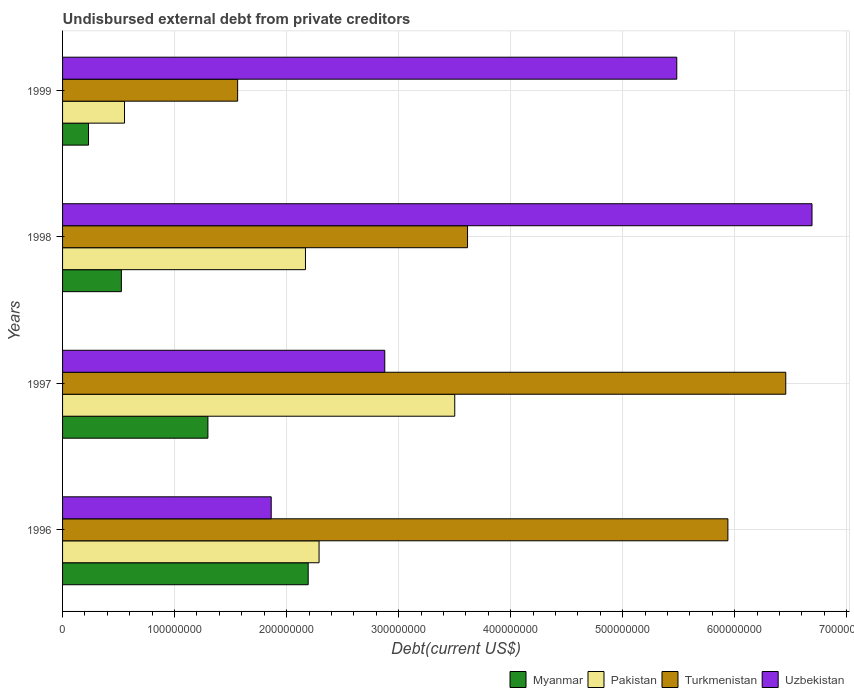How many different coloured bars are there?
Make the answer very short. 4. How many groups of bars are there?
Offer a very short reply. 4. How many bars are there on the 1st tick from the top?
Your answer should be compact. 4. How many bars are there on the 1st tick from the bottom?
Provide a short and direct response. 4. What is the label of the 4th group of bars from the top?
Your answer should be very brief. 1996. What is the total debt in Turkmenistan in 1998?
Your answer should be very brief. 3.62e+08. Across all years, what is the maximum total debt in Pakistan?
Give a very brief answer. 3.50e+08. Across all years, what is the minimum total debt in Uzbekistan?
Offer a terse response. 1.86e+08. What is the total total debt in Pakistan in the graph?
Make the answer very short. 8.51e+08. What is the difference between the total debt in Myanmar in 1997 and that in 1998?
Keep it short and to the point. 7.72e+07. What is the difference between the total debt in Uzbekistan in 1997 and the total debt in Myanmar in 1999?
Make the answer very short. 2.64e+08. What is the average total debt in Uzbekistan per year?
Make the answer very short. 4.23e+08. In the year 1996, what is the difference between the total debt in Pakistan and total debt in Myanmar?
Ensure brevity in your answer.  9.71e+06. What is the ratio of the total debt in Myanmar in 1997 to that in 1998?
Offer a very short reply. 2.47. What is the difference between the highest and the second highest total debt in Turkmenistan?
Make the answer very short. 5.17e+07. What is the difference between the highest and the lowest total debt in Pakistan?
Offer a very short reply. 2.95e+08. Is it the case that in every year, the sum of the total debt in Uzbekistan and total debt in Turkmenistan is greater than the sum of total debt in Myanmar and total debt in Pakistan?
Provide a short and direct response. Yes. What does the 2nd bar from the top in 1998 represents?
Make the answer very short. Turkmenistan. Is it the case that in every year, the sum of the total debt in Turkmenistan and total debt in Myanmar is greater than the total debt in Pakistan?
Provide a short and direct response. Yes. How many years are there in the graph?
Offer a terse response. 4. Are the values on the major ticks of X-axis written in scientific E-notation?
Keep it short and to the point. No. Does the graph contain grids?
Your answer should be very brief. Yes. Where does the legend appear in the graph?
Keep it short and to the point. Bottom right. How many legend labels are there?
Ensure brevity in your answer.  4. What is the title of the graph?
Offer a terse response. Undisbursed external debt from private creditors. Does "Benin" appear as one of the legend labels in the graph?
Offer a terse response. No. What is the label or title of the X-axis?
Keep it short and to the point. Debt(current US$). What is the Debt(current US$) of Myanmar in 1996?
Your response must be concise. 2.19e+08. What is the Debt(current US$) of Pakistan in 1996?
Your answer should be compact. 2.29e+08. What is the Debt(current US$) of Turkmenistan in 1996?
Ensure brevity in your answer.  5.94e+08. What is the Debt(current US$) in Uzbekistan in 1996?
Your answer should be compact. 1.86e+08. What is the Debt(current US$) in Myanmar in 1997?
Give a very brief answer. 1.30e+08. What is the Debt(current US$) of Pakistan in 1997?
Provide a succinct answer. 3.50e+08. What is the Debt(current US$) in Turkmenistan in 1997?
Give a very brief answer. 6.46e+08. What is the Debt(current US$) in Uzbekistan in 1997?
Provide a short and direct response. 2.88e+08. What is the Debt(current US$) of Myanmar in 1998?
Provide a succinct answer. 5.25e+07. What is the Debt(current US$) of Pakistan in 1998?
Make the answer very short. 2.17e+08. What is the Debt(current US$) in Turkmenistan in 1998?
Offer a terse response. 3.62e+08. What is the Debt(current US$) of Uzbekistan in 1998?
Offer a very short reply. 6.69e+08. What is the Debt(current US$) in Myanmar in 1999?
Offer a terse response. 2.32e+07. What is the Debt(current US$) of Pakistan in 1999?
Your answer should be compact. 5.53e+07. What is the Debt(current US$) in Turkmenistan in 1999?
Keep it short and to the point. 1.56e+08. What is the Debt(current US$) of Uzbekistan in 1999?
Give a very brief answer. 5.48e+08. Across all years, what is the maximum Debt(current US$) in Myanmar?
Ensure brevity in your answer.  2.19e+08. Across all years, what is the maximum Debt(current US$) in Pakistan?
Ensure brevity in your answer.  3.50e+08. Across all years, what is the maximum Debt(current US$) in Turkmenistan?
Make the answer very short. 6.46e+08. Across all years, what is the maximum Debt(current US$) of Uzbekistan?
Your answer should be compact. 6.69e+08. Across all years, what is the minimum Debt(current US$) in Myanmar?
Provide a succinct answer. 2.32e+07. Across all years, what is the minimum Debt(current US$) in Pakistan?
Your response must be concise. 5.53e+07. Across all years, what is the minimum Debt(current US$) in Turkmenistan?
Give a very brief answer. 1.56e+08. Across all years, what is the minimum Debt(current US$) of Uzbekistan?
Make the answer very short. 1.86e+08. What is the total Debt(current US$) of Myanmar in the graph?
Make the answer very short. 4.25e+08. What is the total Debt(current US$) of Pakistan in the graph?
Offer a terse response. 8.51e+08. What is the total Debt(current US$) of Turkmenistan in the graph?
Your answer should be compact. 1.76e+09. What is the total Debt(current US$) of Uzbekistan in the graph?
Give a very brief answer. 1.69e+09. What is the difference between the Debt(current US$) in Myanmar in 1996 and that in 1997?
Your response must be concise. 8.95e+07. What is the difference between the Debt(current US$) in Pakistan in 1996 and that in 1997?
Offer a very short reply. -1.21e+08. What is the difference between the Debt(current US$) of Turkmenistan in 1996 and that in 1997?
Keep it short and to the point. -5.17e+07. What is the difference between the Debt(current US$) of Uzbekistan in 1996 and that in 1997?
Your answer should be compact. -1.01e+08. What is the difference between the Debt(current US$) in Myanmar in 1996 and that in 1998?
Keep it short and to the point. 1.67e+08. What is the difference between the Debt(current US$) of Pakistan in 1996 and that in 1998?
Make the answer very short. 1.21e+07. What is the difference between the Debt(current US$) of Turkmenistan in 1996 and that in 1998?
Ensure brevity in your answer.  2.32e+08. What is the difference between the Debt(current US$) of Uzbekistan in 1996 and that in 1998?
Offer a very short reply. -4.83e+08. What is the difference between the Debt(current US$) of Myanmar in 1996 and that in 1999?
Make the answer very short. 1.96e+08. What is the difference between the Debt(current US$) of Pakistan in 1996 and that in 1999?
Make the answer very short. 1.74e+08. What is the difference between the Debt(current US$) in Turkmenistan in 1996 and that in 1999?
Make the answer very short. 4.38e+08. What is the difference between the Debt(current US$) of Uzbekistan in 1996 and that in 1999?
Offer a terse response. -3.62e+08. What is the difference between the Debt(current US$) in Myanmar in 1997 and that in 1998?
Make the answer very short. 7.72e+07. What is the difference between the Debt(current US$) in Pakistan in 1997 and that in 1998?
Provide a succinct answer. 1.33e+08. What is the difference between the Debt(current US$) of Turkmenistan in 1997 and that in 1998?
Offer a very short reply. 2.84e+08. What is the difference between the Debt(current US$) in Uzbekistan in 1997 and that in 1998?
Offer a very short reply. -3.81e+08. What is the difference between the Debt(current US$) of Myanmar in 1997 and that in 1999?
Offer a very short reply. 1.07e+08. What is the difference between the Debt(current US$) of Pakistan in 1997 and that in 1999?
Offer a terse response. 2.95e+08. What is the difference between the Debt(current US$) of Turkmenistan in 1997 and that in 1999?
Ensure brevity in your answer.  4.89e+08. What is the difference between the Debt(current US$) in Uzbekistan in 1997 and that in 1999?
Offer a very short reply. -2.61e+08. What is the difference between the Debt(current US$) of Myanmar in 1998 and that in 1999?
Provide a short and direct response. 2.93e+07. What is the difference between the Debt(current US$) of Pakistan in 1998 and that in 1999?
Offer a very short reply. 1.62e+08. What is the difference between the Debt(current US$) of Turkmenistan in 1998 and that in 1999?
Your answer should be very brief. 2.05e+08. What is the difference between the Debt(current US$) in Uzbekistan in 1998 and that in 1999?
Provide a short and direct response. 1.21e+08. What is the difference between the Debt(current US$) in Myanmar in 1996 and the Debt(current US$) in Pakistan in 1997?
Ensure brevity in your answer.  -1.31e+08. What is the difference between the Debt(current US$) in Myanmar in 1996 and the Debt(current US$) in Turkmenistan in 1997?
Provide a succinct answer. -4.26e+08. What is the difference between the Debt(current US$) in Myanmar in 1996 and the Debt(current US$) in Uzbekistan in 1997?
Provide a short and direct response. -6.84e+07. What is the difference between the Debt(current US$) of Pakistan in 1996 and the Debt(current US$) of Turkmenistan in 1997?
Your answer should be compact. -4.17e+08. What is the difference between the Debt(current US$) in Pakistan in 1996 and the Debt(current US$) in Uzbekistan in 1997?
Keep it short and to the point. -5.87e+07. What is the difference between the Debt(current US$) in Turkmenistan in 1996 and the Debt(current US$) in Uzbekistan in 1997?
Your answer should be compact. 3.06e+08. What is the difference between the Debt(current US$) in Myanmar in 1996 and the Debt(current US$) in Pakistan in 1998?
Offer a terse response. 2.43e+06. What is the difference between the Debt(current US$) in Myanmar in 1996 and the Debt(current US$) in Turkmenistan in 1998?
Your answer should be very brief. -1.42e+08. What is the difference between the Debt(current US$) in Myanmar in 1996 and the Debt(current US$) in Uzbekistan in 1998?
Provide a short and direct response. -4.50e+08. What is the difference between the Debt(current US$) of Pakistan in 1996 and the Debt(current US$) of Turkmenistan in 1998?
Provide a succinct answer. -1.33e+08. What is the difference between the Debt(current US$) of Pakistan in 1996 and the Debt(current US$) of Uzbekistan in 1998?
Keep it short and to the point. -4.40e+08. What is the difference between the Debt(current US$) in Turkmenistan in 1996 and the Debt(current US$) in Uzbekistan in 1998?
Your response must be concise. -7.51e+07. What is the difference between the Debt(current US$) of Myanmar in 1996 and the Debt(current US$) of Pakistan in 1999?
Provide a succinct answer. 1.64e+08. What is the difference between the Debt(current US$) in Myanmar in 1996 and the Debt(current US$) in Turkmenistan in 1999?
Your answer should be very brief. 6.30e+07. What is the difference between the Debt(current US$) in Myanmar in 1996 and the Debt(current US$) in Uzbekistan in 1999?
Give a very brief answer. -3.29e+08. What is the difference between the Debt(current US$) of Pakistan in 1996 and the Debt(current US$) of Turkmenistan in 1999?
Provide a short and direct response. 7.27e+07. What is the difference between the Debt(current US$) in Pakistan in 1996 and the Debt(current US$) in Uzbekistan in 1999?
Your answer should be very brief. -3.19e+08. What is the difference between the Debt(current US$) of Turkmenistan in 1996 and the Debt(current US$) of Uzbekistan in 1999?
Your answer should be compact. 4.56e+07. What is the difference between the Debt(current US$) in Myanmar in 1997 and the Debt(current US$) in Pakistan in 1998?
Offer a very short reply. -8.71e+07. What is the difference between the Debt(current US$) of Myanmar in 1997 and the Debt(current US$) of Turkmenistan in 1998?
Provide a succinct answer. -2.32e+08. What is the difference between the Debt(current US$) of Myanmar in 1997 and the Debt(current US$) of Uzbekistan in 1998?
Give a very brief answer. -5.39e+08. What is the difference between the Debt(current US$) in Pakistan in 1997 and the Debt(current US$) in Turkmenistan in 1998?
Give a very brief answer. -1.14e+07. What is the difference between the Debt(current US$) of Pakistan in 1997 and the Debt(current US$) of Uzbekistan in 1998?
Give a very brief answer. -3.19e+08. What is the difference between the Debt(current US$) in Turkmenistan in 1997 and the Debt(current US$) in Uzbekistan in 1998?
Make the answer very short. -2.34e+07. What is the difference between the Debt(current US$) in Myanmar in 1997 and the Debt(current US$) in Pakistan in 1999?
Offer a very short reply. 7.44e+07. What is the difference between the Debt(current US$) of Myanmar in 1997 and the Debt(current US$) of Turkmenistan in 1999?
Provide a succinct answer. -2.66e+07. What is the difference between the Debt(current US$) of Myanmar in 1997 and the Debt(current US$) of Uzbekistan in 1999?
Your answer should be compact. -4.19e+08. What is the difference between the Debt(current US$) of Pakistan in 1997 and the Debt(current US$) of Turkmenistan in 1999?
Offer a very short reply. 1.94e+08. What is the difference between the Debt(current US$) in Pakistan in 1997 and the Debt(current US$) in Uzbekistan in 1999?
Your answer should be very brief. -1.98e+08. What is the difference between the Debt(current US$) in Turkmenistan in 1997 and the Debt(current US$) in Uzbekistan in 1999?
Your answer should be very brief. 9.73e+07. What is the difference between the Debt(current US$) in Myanmar in 1998 and the Debt(current US$) in Pakistan in 1999?
Make the answer very short. -2.81e+06. What is the difference between the Debt(current US$) of Myanmar in 1998 and the Debt(current US$) of Turkmenistan in 1999?
Make the answer very short. -1.04e+08. What is the difference between the Debt(current US$) in Myanmar in 1998 and the Debt(current US$) in Uzbekistan in 1999?
Offer a very short reply. -4.96e+08. What is the difference between the Debt(current US$) in Pakistan in 1998 and the Debt(current US$) in Turkmenistan in 1999?
Ensure brevity in your answer.  6.05e+07. What is the difference between the Debt(current US$) in Pakistan in 1998 and the Debt(current US$) in Uzbekistan in 1999?
Your answer should be compact. -3.31e+08. What is the difference between the Debt(current US$) of Turkmenistan in 1998 and the Debt(current US$) of Uzbekistan in 1999?
Provide a short and direct response. -1.87e+08. What is the average Debt(current US$) in Myanmar per year?
Give a very brief answer. 1.06e+08. What is the average Debt(current US$) of Pakistan per year?
Ensure brevity in your answer.  2.13e+08. What is the average Debt(current US$) in Turkmenistan per year?
Your answer should be compact. 4.39e+08. What is the average Debt(current US$) in Uzbekistan per year?
Your answer should be very brief. 4.23e+08. In the year 1996, what is the difference between the Debt(current US$) in Myanmar and Debt(current US$) in Pakistan?
Ensure brevity in your answer.  -9.71e+06. In the year 1996, what is the difference between the Debt(current US$) of Myanmar and Debt(current US$) of Turkmenistan?
Offer a very short reply. -3.75e+08. In the year 1996, what is the difference between the Debt(current US$) in Myanmar and Debt(current US$) in Uzbekistan?
Offer a very short reply. 3.30e+07. In the year 1996, what is the difference between the Debt(current US$) in Pakistan and Debt(current US$) in Turkmenistan?
Make the answer very short. -3.65e+08. In the year 1996, what is the difference between the Debt(current US$) in Pakistan and Debt(current US$) in Uzbekistan?
Provide a succinct answer. 4.27e+07. In the year 1996, what is the difference between the Debt(current US$) in Turkmenistan and Debt(current US$) in Uzbekistan?
Offer a terse response. 4.08e+08. In the year 1997, what is the difference between the Debt(current US$) in Myanmar and Debt(current US$) in Pakistan?
Provide a succinct answer. -2.20e+08. In the year 1997, what is the difference between the Debt(current US$) of Myanmar and Debt(current US$) of Turkmenistan?
Provide a succinct answer. -5.16e+08. In the year 1997, what is the difference between the Debt(current US$) of Myanmar and Debt(current US$) of Uzbekistan?
Offer a terse response. -1.58e+08. In the year 1997, what is the difference between the Debt(current US$) of Pakistan and Debt(current US$) of Turkmenistan?
Provide a succinct answer. -2.95e+08. In the year 1997, what is the difference between the Debt(current US$) in Pakistan and Debt(current US$) in Uzbekistan?
Offer a terse response. 6.25e+07. In the year 1997, what is the difference between the Debt(current US$) of Turkmenistan and Debt(current US$) of Uzbekistan?
Keep it short and to the point. 3.58e+08. In the year 1998, what is the difference between the Debt(current US$) in Myanmar and Debt(current US$) in Pakistan?
Give a very brief answer. -1.64e+08. In the year 1998, what is the difference between the Debt(current US$) of Myanmar and Debt(current US$) of Turkmenistan?
Provide a short and direct response. -3.09e+08. In the year 1998, what is the difference between the Debt(current US$) of Myanmar and Debt(current US$) of Uzbekistan?
Offer a terse response. -6.17e+08. In the year 1998, what is the difference between the Debt(current US$) of Pakistan and Debt(current US$) of Turkmenistan?
Your response must be concise. -1.45e+08. In the year 1998, what is the difference between the Debt(current US$) in Pakistan and Debt(current US$) in Uzbekistan?
Keep it short and to the point. -4.52e+08. In the year 1998, what is the difference between the Debt(current US$) of Turkmenistan and Debt(current US$) of Uzbekistan?
Give a very brief answer. -3.08e+08. In the year 1999, what is the difference between the Debt(current US$) of Myanmar and Debt(current US$) of Pakistan?
Provide a succinct answer. -3.21e+07. In the year 1999, what is the difference between the Debt(current US$) in Myanmar and Debt(current US$) in Turkmenistan?
Offer a very short reply. -1.33e+08. In the year 1999, what is the difference between the Debt(current US$) of Myanmar and Debt(current US$) of Uzbekistan?
Make the answer very short. -5.25e+08. In the year 1999, what is the difference between the Debt(current US$) in Pakistan and Debt(current US$) in Turkmenistan?
Give a very brief answer. -1.01e+08. In the year 1999, what is the difference between the Debt(current US$) in Pakistan and Debt(current US$) in Uzbekistan?
Your response must be concise. -4.93e+08. In the year 1999, what is the difference between the Debt(current US$) in Turkmenistan and Debt(current US$) in Uzbekistan?
Provide a succinct answer. -3.92e+08. What is the ratio of the Debt(current US$) in Myanmar in 1996 to that in 1997?
Your answer should be very brief. 1.69. What is the ratio of the Debt(current US$) in Pakistan in 1996 to that in 1997?
Your response must be concise. 0.65. What is the ratio of the Debt(current US$) of Uzbekistan in 1996 to that in 1997?
Offer a very short reply. 0.65. What is the ratio of the Debt(current US$) in Myanmar in 1996 to that in 1998?
Your response must be concise. 4.18. What is the ratio of the Debt(current US$) of Pakistan in 1996 to that in 1998?
Offer a terse response. 1.06. What is the ratio of the Debt(current US$) of Turkmenistan in 1996 to that in 1998?
Offer a terse response. 1.64. What is the ratio of the Debt(current US$) of Uzbekistan in 1996 to that in 1998?
Keep it short and to the point. 0.28. What is the ratio of the Debt(current US$) in Myanmar in 1996 to that in 1999?
Provide a short and direct response. 9.47. What is the ratio of the Debt(current US$) in Pakistan in 1996 to that in 1999?
Make the answer very short. 4.14. What is the ratio of the Debt(current US$) in Turkmenistan in 1996 to that in 1999?
Give a very brief answer. 3.8. What is the ratio of the Debt(current US$) of Uzbekistan in 1996 to that in 1999?
Your answer should be compact. 0.34. What is the ratio of the Debt(current US$) in Myanmar in 1997 to that in 1998?
Give a very brief answer. 2.47. What is the ratio of the Debt(current US$) in Pakistan in 1997 to that in 1998?
Make the answer very short. 1.61. What is the ratio of the Debt(current US$) of Turkmenistan in 1997 to that in 1998?
Your answer should be very brief. 1.79. What is the ratio of the Debt(current US$) in Uzbekistan in 1997 to that in 1998?
Give a very brief answer. 0.43. What is the ratio of the Debt(current US$) in Myanmar in 1997 to that in 1999?
Offer a terse response. 5.6. What is the ratio of the Debt(current US$) of Pakistan in 1997 to that in 1999?
Provide a short and direct response. 6.33. What is the ratio of the Debt(current US$) of Turkmenistan in 1997 to that in 1999?
Your response must be concise. 4.13. What is the ratio of the Debt(current US$) in Uzbekistan in 1997 to that in 1999?
Your response must be concise. 0.52. What is the ratio of the Debt(current US$) in Myanmar in 1998 to that in 1999?
Keep it short and to the point. 2.27. What is the ratio of the Debt(current US$) in Pakistan in 1998 to that in 1999?
Your answer should be compact. 3.92. What is the ratio of the Debt(current US$) of Turkmenistan in 1998 to that in 1999?
Offer a terse response. 2.31. What is the ratio of the Debt(current US$) of Uzbekistan in 1998 to that in 1999?
Offer a terse response. 1.22. What is the difference between the highest and the second highest Debt(current US$) of Myanmar?
Make the answer very short. 8.95e+07. What is the difference between the highest and the second highest Debt(current US$) of Pakistan?
Your answer should be compact. 1.21e+08. What is the difference between the highest and the second highest Debt(current US$) of Turkmenistan?
Your answer should be compact. 5.17e+07. What is the difference between the highest and the second highest Debt(current US$) of Uzbekistan?
Your answer should be very brief. 1.21e+08. What is the difference between the highest and the lowest Debt(current US$) of Myanmar?
Make the answer very short. 1.96e+08. What is the difference between the highest and the lowest Debt(current US$) in Pakistan?
Give a very brief answer. 2.95e+08. What is the difference between the highest and the lowest Debt(current US$) of Turkmenistan?
Your answer should be very brief. 4.89e+08. What is the difference between the highest and the lowest Debt(current US$) of Uzbekistan?
Your answer should be compact. 4.83e+08. 